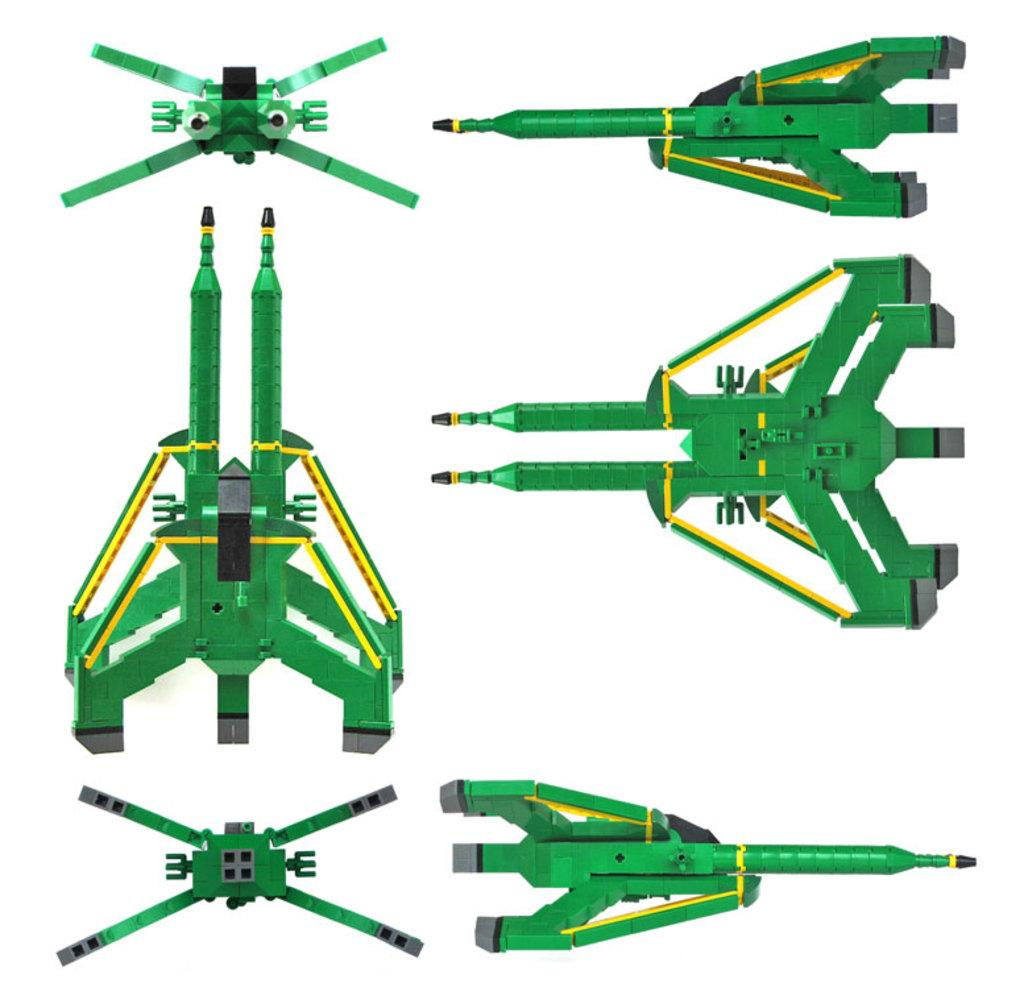What type of objects are depicted in the picture? The picture contains images of missiles and rockets. Are there any other objects in the picture besides missiles and rockets? Yes, there are other objects in the picture. What color are the missiles, rockets, and other objects in the picture? They are in green color. What is the color of the background in the picture? The background is white color. Can you see any lizards crawling on the missiles in the picture? No, there are no lizards present in the image. What type of creature is shown interacting with the missiles in the picture? There is no creature shown interacting with the missiles in the picture; only the missiles, rockets, and other objects are present. 